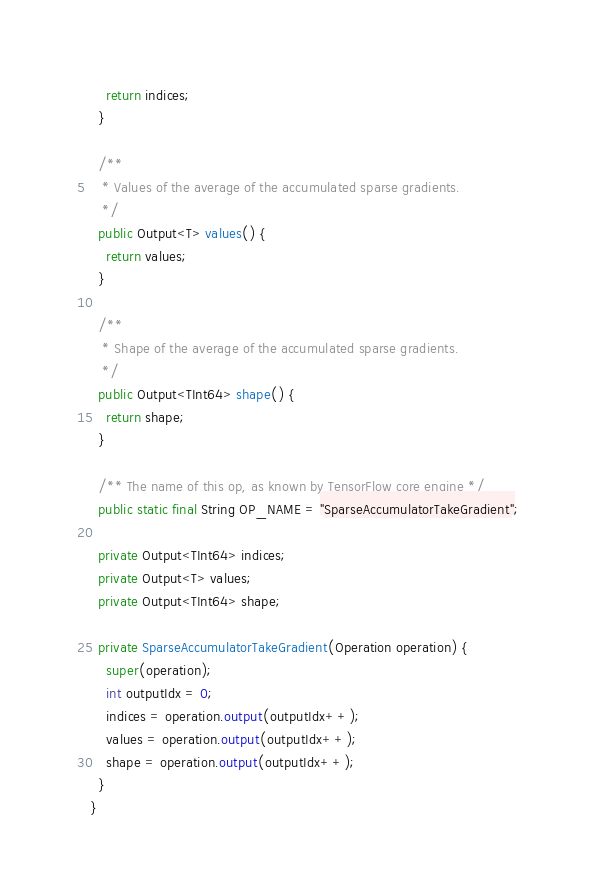Convert code to text. <code><loc_0><loc_0><loc_500><loc_500><_Java_>    return indices;
  }
  
  /**
   * Values of the average of the accumulated sparse gradients.
   */
  public Output<T> values() {
    return values;
  }
  
  /**
   * Shape of the average of the accumulated sparse gradients.
   */
  public Output<TInt64> shape() {
    return shape;
  }
  
  /** The name of this op, as known by TensorFlow core engine */
  public static final String OP_NAME = "SparseAccumulatorTakeGradient";
  
  private Output<TInt64> indices;
  private Output<T> values;
  private Output<TInt64> shape;
  
  private SparseAccumulatorTakeGradient(Operation operation) {
    super(operation);
    int outputIdx = 0;
    indices = operation.output(outputIdx++);
    values = operation.output(outputIdx++);
    shape = operation.output(outputIdx++);
  }
}
</code> 